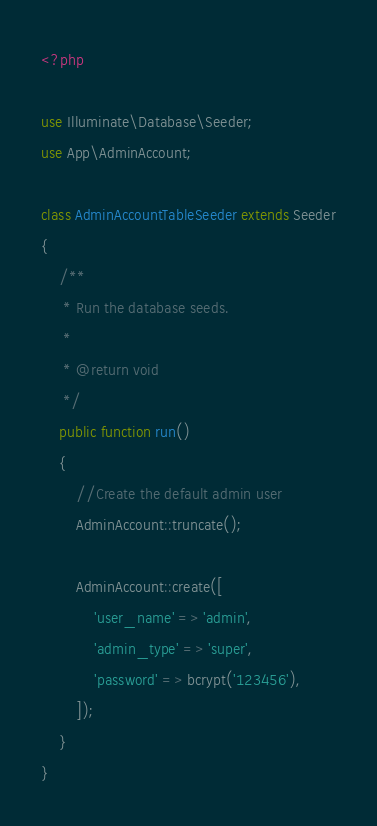Convert code to text. <code><loc_0><loc_0><loc_500><loc_500><_PHP_><?php

use Illuminate\Database\Seeder;
use App\AdminAccount;

class AdminAccountTableSeeder extends Seeder
{
    /**
     * Run the database seeds.
     *
     * @return void
     */
    public function run()
    {
        //Create the default admin user
        AdminAccount::truncate();

        AdminAccount::create([
            'user_name' => 'admin',
            'admin_type' => 'super',
            'password' => bcrypt('123456'),
        ]);
    }
}
</code> 